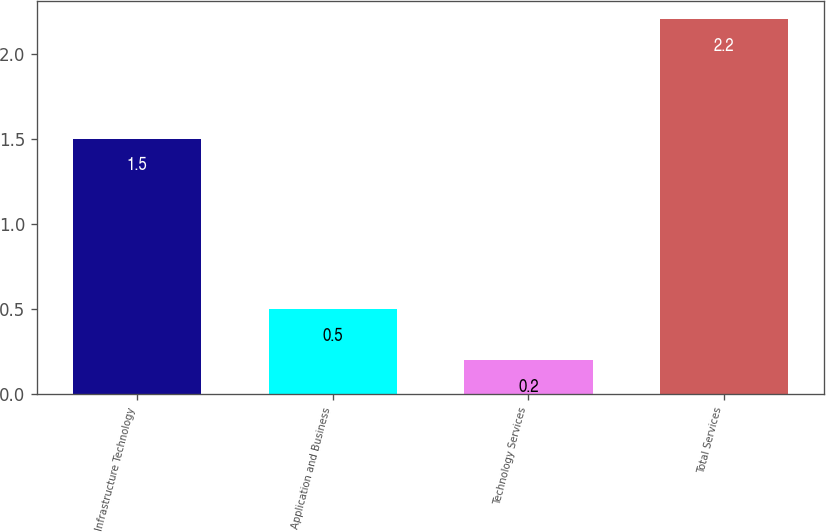<chart> <loc_0><loc_0><loc_500><loc_500><bar_chart><fcel>Infrastructure Technology<fcel>Application and Business<fcel>Technology Services<fcel>Total Services<nl><fcel>1.5<fcel>0.5<fcel>0.2<fcel>2.2<nl></chart> 